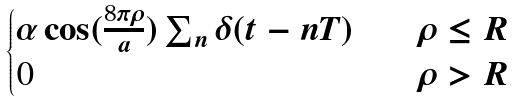<formula> <loc_0><loc_0><loc_500><loc_500>\begin{cases} \alpha \cos ( \frac { 8 \pi \rho } { a } ) \sum _ { n } \delta ( t - n T ) \quad & \rho \leq R \\ 0 & \rho > R \\ \end{cases}</formula> 